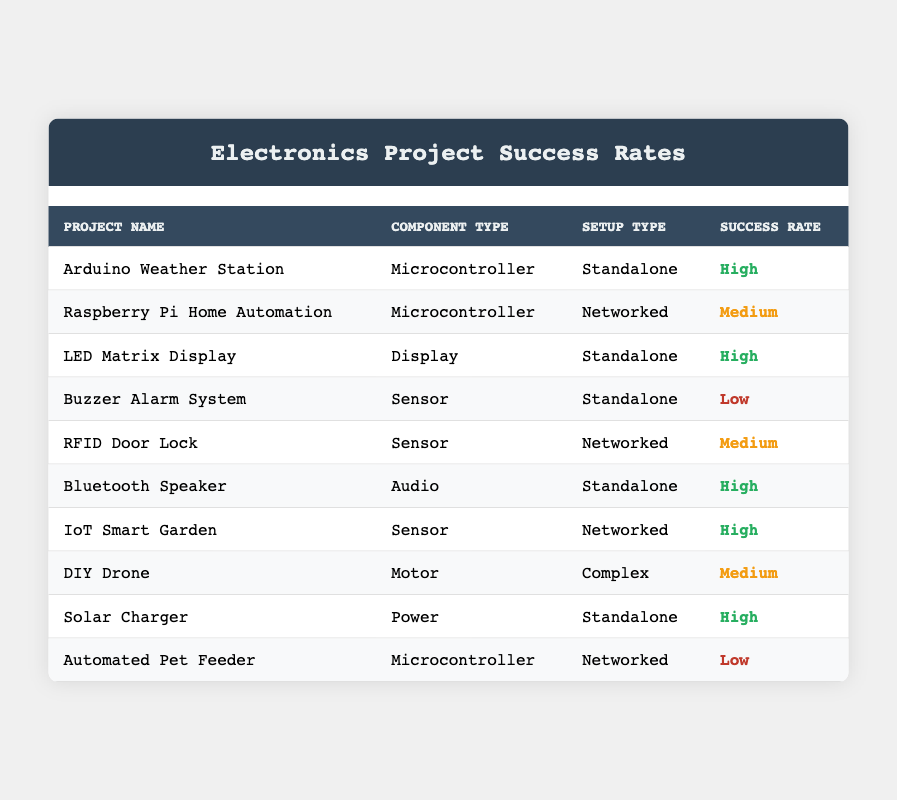What is the success rate of the Arduino Weather Station? The table states that the success rate for the Arduino Weather Station is "High."
Answer: High How many projects have a "High" success rate? By counting the rows in the table, there are four projects with a "High" success rate: Arduino Weather Station, LED Matrix Display, Bluetooth Speaker, and IoT Smart Garden.
Answer: 4 Are there any projects with a "Low" success rate using the Sensor component type? The Buzzer Alarm System is listed with a "Low" success rate and it uses the Sensor component type. Therefore, the answer is yes.
Answer: Yes What component type has the highest number of projects listed in the table? By examining the table, the Microcontroller component type appears three times (Arduino Weather Station, Raspberry Pi Home Automation, Automated Pet Feeder), which is the highest frequency of any component type.
Answer: Microcontroller What is the average success rate of projects using Motor components? There is only one project using Motor components, which is the DIY Drone with a "Medium" success rate, so the average is just "Medium."
Answer: Medium Is the success rate of Networked setups generally higher than Standalone setups? To determine this, we check the success rates of Networked setups (Medium, Medium, High) and Standalone setups (High, High, High) and see that the average for Networked is approximately Medium while Standalone averages High, indicating that Standalone setups generally have higher success rates.
Answer: No How many projects classified as "Standalone" have a success rate lower than "High"? The Buzzer Alarm System is the only Standalone project with a success rate of "Low." Thus, there is one project that fits this criterion.
Answer: 1 Which setup type has the most projects with a "Medium" success rate? The Networked setup type has two projects with a "Medium" success rate (Raspberry Pi Home Automation, RFID Door Lock), while Standalone has one project (Buzzer Alarm System). Therefore, Networked is the type with the most "Medium" successes.
Answer: Networked Which project has the "Lowest" success rate? The Automated Pet Feeder is the only project listed with a "Low" success rate.
Answer: Automated Pet Feeder 